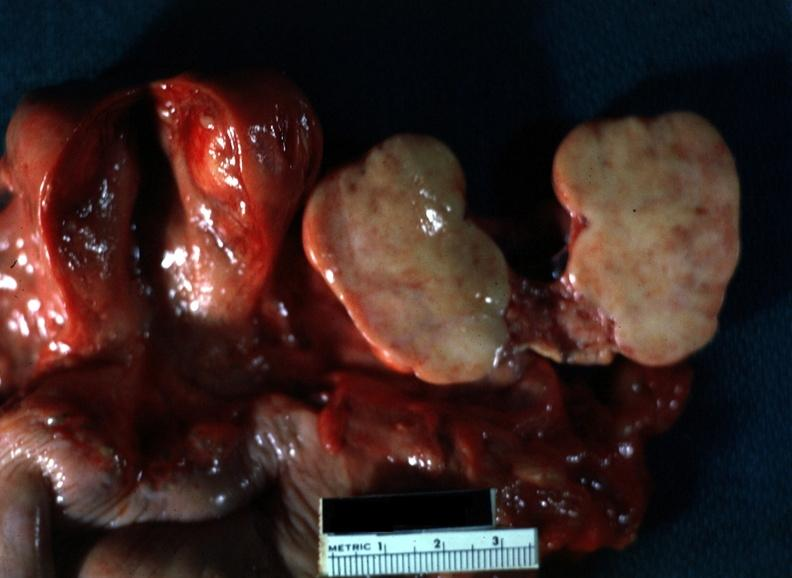s acrocyanosis present?
Answer the question using a single word or phrase. No 